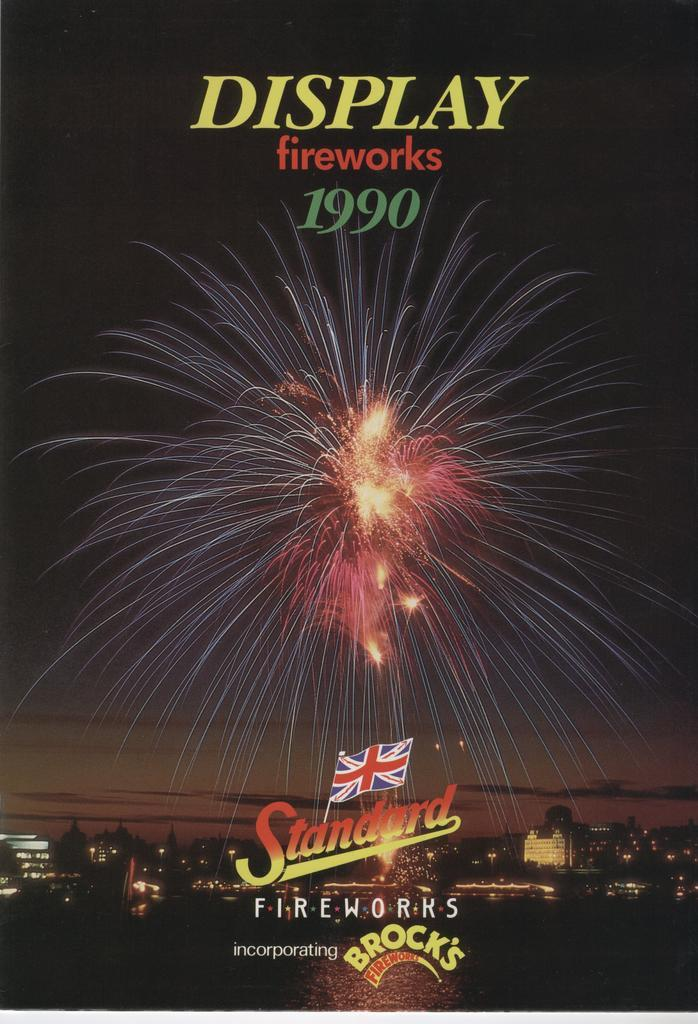<image>
Give a short and clear explanation of the subsequent image. Brock's Fireworks is advertised with an ad for a display in 1990. 